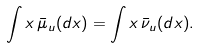Convert formula to latex. <formula><loc_0><loc_0><loc_500><loc_500>\int x \, \bar { \mu } _ { u } ( d x ) = \int x \, \bar { \nu } _ { u } ( d x ) .</formula> 